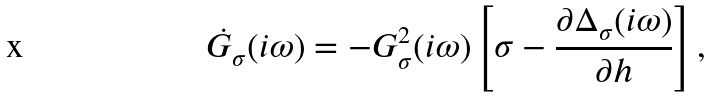Convert formula to latex. <formula><loc_0><loc_0><loc_500><loc_500>\dot { G } _ { \sigma } ( i \omega ) = - { G } ^ { 2 } _ { \sigma } ( i \omega ) \left [ \sigma - \frac { \partial \Delta _ { \sigma } ( i \omega ) } { \partial h } \right ] ,</formula> 